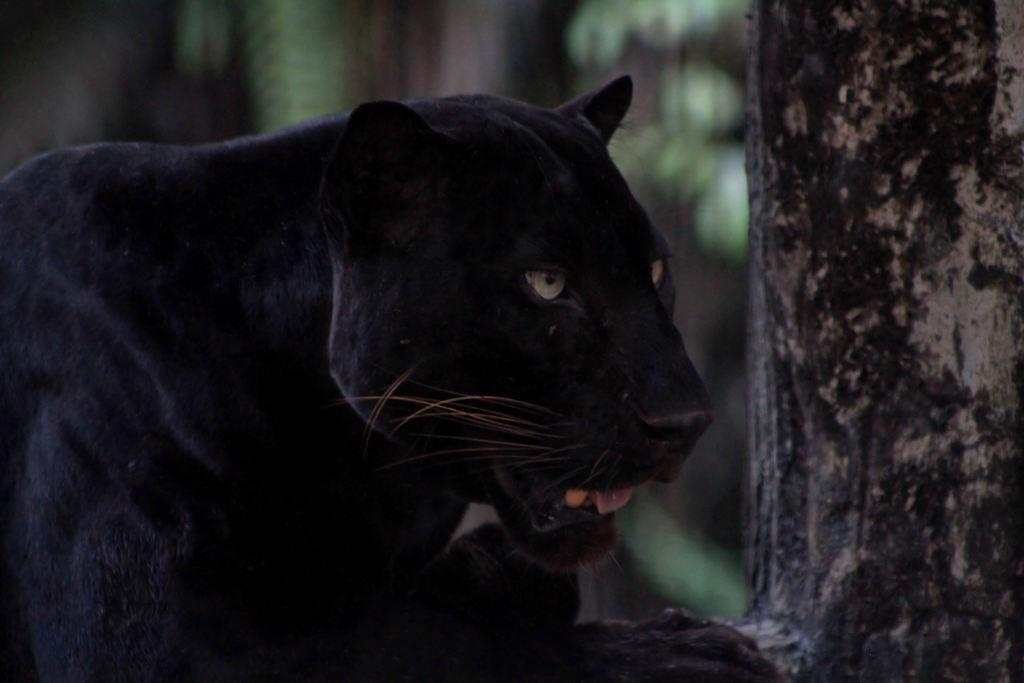What type of animal is present in the image? There is an animal in the image, but its specific type cannot be determined from the provided facts. What other object can be seen in the image besides the animal? There is a tree trunk in the image. What type of soda is being poured from the tree trunk in the image? There is no soda present in the image, as it only features an animal and a tree trunk. 